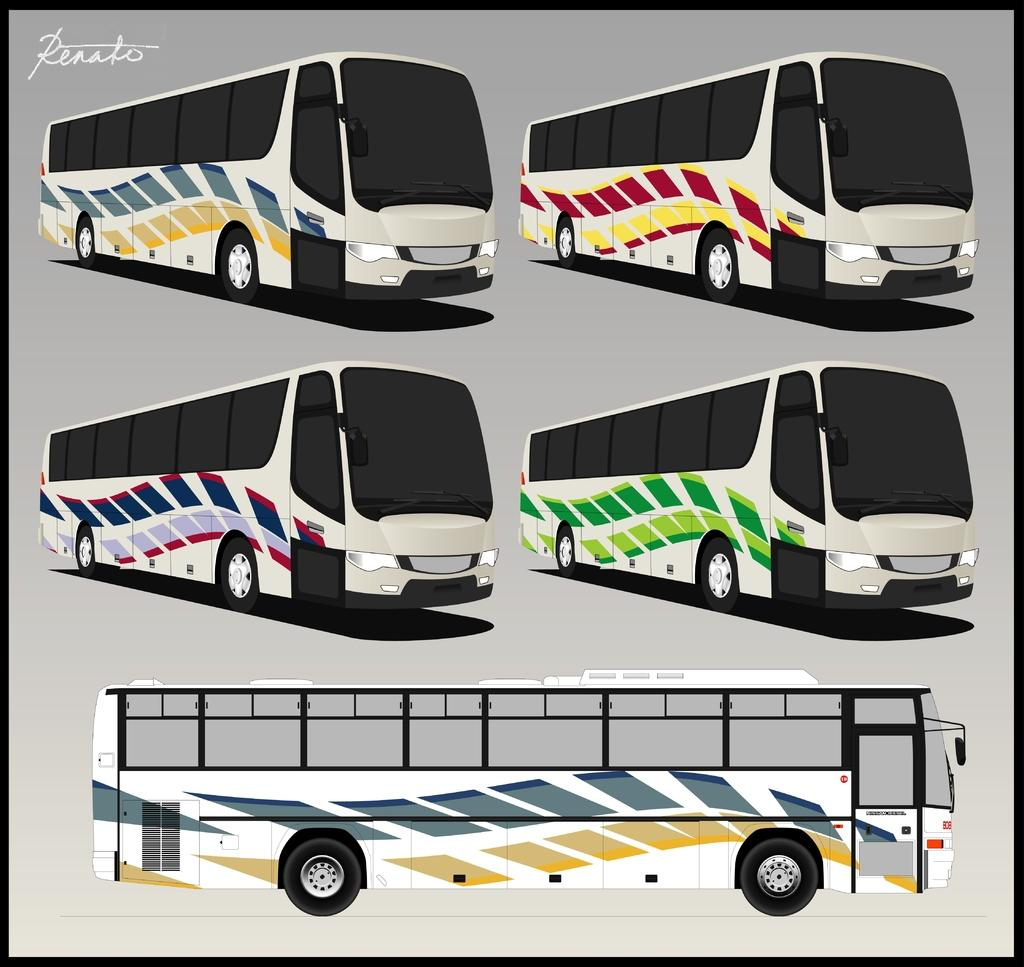What is the main subject of the image? The main subject of the image is an art of buses. Can you describe the appearance of the buses in the image? The buses are in various colors. How many balloons are attached to the buses in the image? There are no balloons present in the image; it features an art of buses in various colors. What type of military vehicle can be seen near the buses in the image? There is no military vehicle, such as a tank, present in the image; it only features buses in various colors. 